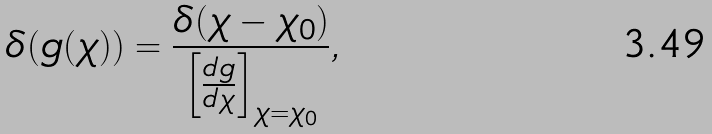Convert formula to latex. <formula><loc_0><loc_0><loc_500><loc_500>\delta ( g ( \chi ) ) = \frac { \delta ( \chi - \chi _ { 0 } ) } { \left [ \frac { d g } { d \chi } \right ] _ { \chi = \chi _ { 0 } } } ,</formula> 